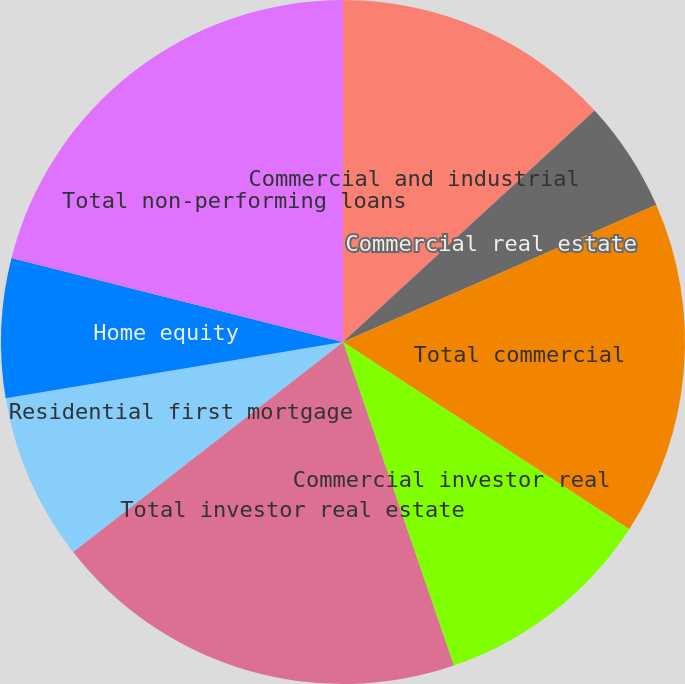Convert chart. <chart><loc_0><loc_0><loc_500><loc_500><pie_chart><fcel>Commercial and industrial<fcel>Commercial real estate<fcel>Total commercial<fcel>Commercial investor real<fcel>Total investor real estate<fcel>Residential first mortgage<fcel>Home equity<fcel>Total non-performing loans<nl><fcel>13.16%<fcel>5.27%<fcel>15.79%<fcel>10.53%<fcel>19.73%<fcel>7.9%<fcel>6.58%<fcel>21.05%<nl></chart> 